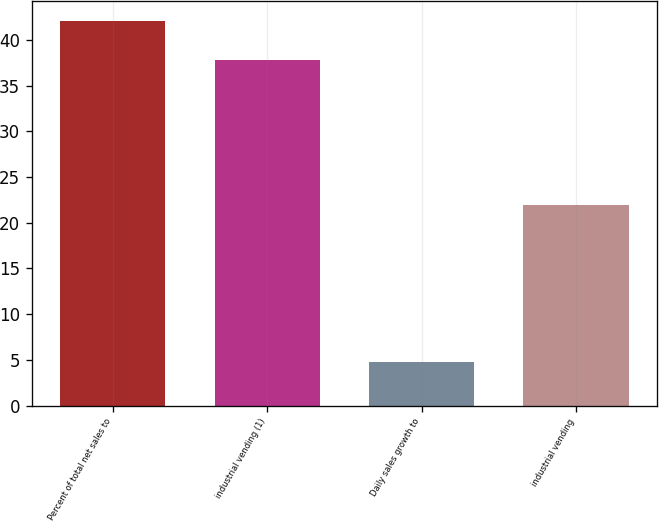Convert chart. <chart><loc_0><loc_0><loc_500><loc_500><bar_chart><fcel>Percent of total net sales to<fcel>industrial vending (1)<fcel>Daily sales growth to<fcel>industrial vending<nl><fcel>42.1<fcel>37.8<fcel>4.8<fcel>21.9<nl></chart> 